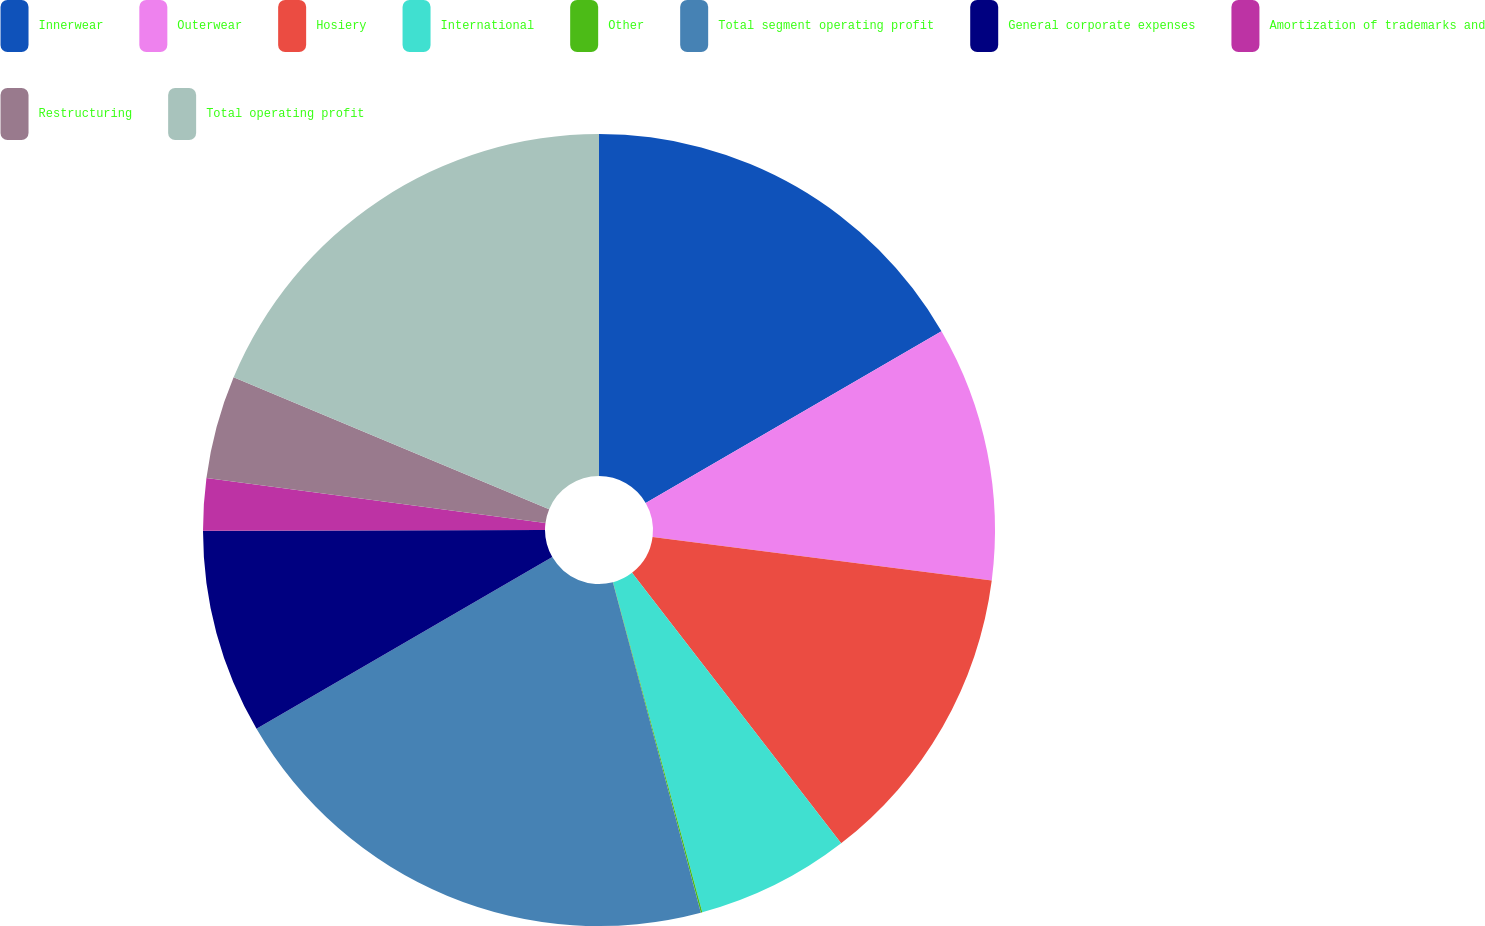Convert chart to OTSL. <chart><loc_0><loc_0><loc_500><loc_500><pie_chart><fcel>Innerwear<fcel>Outerwear<fcel>Hosiery<fcel>International<fcel>Other<fcel>Total segment operating profit<fcel>General corporate expenses<fcel>Amortization of trademarks and<fcel>Restructuring<fcel>Total operating profit<nl><fcel>16.63%<fcel>10.41%<fcel>12.49%<fcel>6.27%<fcel>0.06%<fcel>20.77%<fcel>8.34%<fcel>2.13%<fcel>4.2%<fcel>18.7%<nl></chart> 